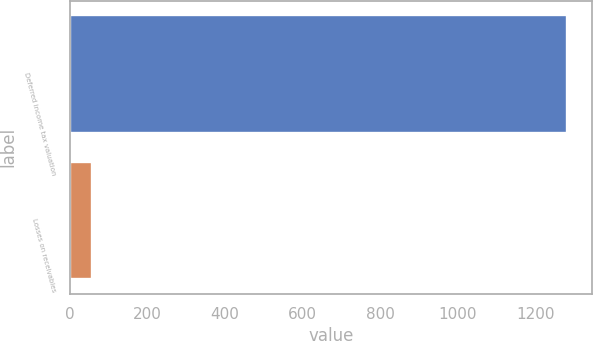Convert chart to OTSL. <chart><loc_0><loc_0><loc_500><loc_500><bar_chart><fcel>Deferred income tax valuation<fcel>Losses on receivables<nl><fcel>1282<fcel>58<nl></chart> 